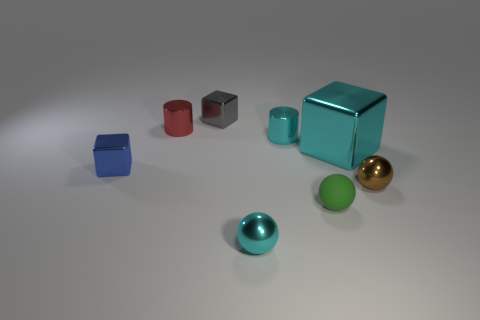Add 2 cyan cylinders. How many objects exist? 10 Subtract all cylinders. How many objects are left? 6 Subtract 0 purple cylinders. How many objects are left? 8 Subtract all green spheres. Subtract all balls. How many objects are left? 4 Add 3 cyan spheres. How many cyan spheres are left? 4 Add 3 large yellow cubes. How many large yellow cubes exist? 3 